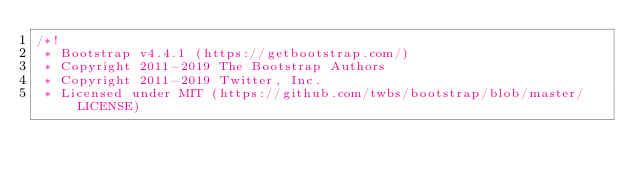Convert code to text. <code><loc_0><loc_0><loc_500><loc_500><_CSS_>/*!
 * Bootstrap v4.4.1 (https://getbootstrap.com/)
 * Copyright 2011-2019 The Bootstrap Authors
 * Copyright 2011-2019 Twitter, Inc.
 * Licensed under MIT (https://github.com/twbs/bootstrap/blob/master/LICENSE)</code> 